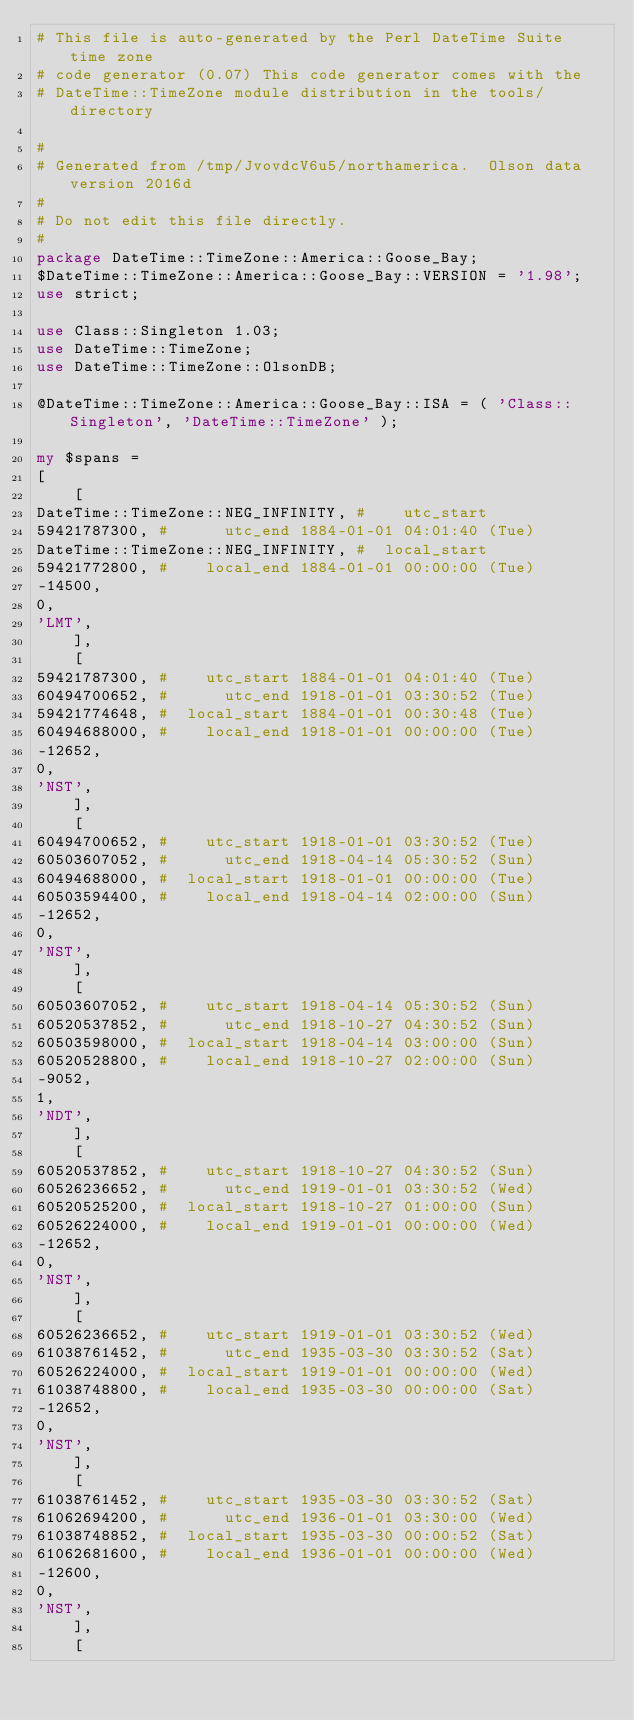Convert code to text. <code><loc_0><loc_0><loc_500><loc_500><_Perl_># This file is auto-generated by the Perl DateTime Suite time zone
# code generator (0.07) This code generator comes with the
# DateTime::TimeZone module distribution in the tools/ directory

#
# Generated from /tmp/JvovdcV6u5/northamerica.  Olson data version 2016d
#
# Do not edit this file directly.
#
package DateTime::TimeZone::America::Goose_Bay;
$DateTime::TimeZone::America::Goose_Bay::VERSION = '1.98';
use strict;

use Class::Singleton 1.03;
use DateTime::TimeZone;
use DateTime::TimeZone::OlsonDB;

@DateTime::TimeZone::America::Goose_Bay::ISA = ( 'Class::Singleton', 'DateTime::TimeZone' );

my $spans =
[
    [
DateTime::TimeZone::NEG_INFINITY, #    utc_start
59421787300, #      utc_end 1884-01-01 04:01:40 (Tue)
DateTime::TimeZone::NEG_INFINITY, #  local_start
59421772800, #    local_end 1884-01-01 00:00:00 (Tue)
-14500,
0,
'LMT',
    ],
    [
59421787300, #    utc_start 1884-01-01 04:01:40 (Tue)
60494700652, #      utc_end 1918-01-01 03:30:52 (Tue)
59421774648, #  local_start 1884-01-01 00:30:48 (Tue)
60494688000, #    local_end 1918-01-01 00:00:00 (Tue)
-12652,
0,
'NST',
    ],
    [
60494700652, #    utc_start 1918-01-01 03:30:52 (Tue)
60503607052, #      utc_end 1918-04-14 05:30:52 (Sun)
60494688000, #  local_start 1918-01-01 00:00:00 (Tue)
60503594400, #    local_end 1918-04-14 02:00:00 (Sun)
-12652,
0,
'NST',
    ],
    [
60503607052, #    utc_start 1918-04-14 05:30:52 (Sun)
60520537852, #      utc_end 1918-10-27 04:30:52 (Sun)
60503598000, #  local_start 1918-04-14 03:00:00 (Sun)
60520528800, #    local_end 1918-10-27 02:00:00 (Sun)
-9052,
1,
'NDT',
    ],
    [
60520537852, #    utc_start 1918-10-27 04:30:52 (Sun)
60526236652, #      utc_end 1919-01-01 03:30:52 (Wed)
60520525200, #  local_start 1918-10-27 01:00:00 (Sun)
60526224000, #    local_end 1919-01-01 00:00:00 (Wed)
-12652,
0,
'NST',
    ],
    [
60526236652, #    utc_start 1919-01-01 03:30:52 (Wed)
61038761452, #      utc_end 1935-03-30 03:30:52 (Sat)
60526224000, #  local_start 1919-01-01 00:00:00 (Wed)
61038748800, #    local_end 1935-03-30 00:00:00 (Sat)
-12652,
0,
'NST',
    ],
    [
61038761452, #    utc_start 1935-03-30 03:30:52 (Sat)
61062694200, #      utc_end 1936-01-01 03:30:00 (Wed)
61038748852, #  local_start 1935-03-30 00:00:52 (Sat)
61062681600, #    local_end 1936-01-01 00:00:00 (Wed)
-12600,
0,
'NST',
    ],
    [</code> 